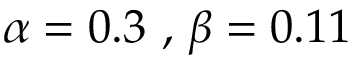<formula> <loc_0><loc_0><loc_500><loc_500>\alpha = 0 . 3 , \beta = 0 . 1 1</formula> 